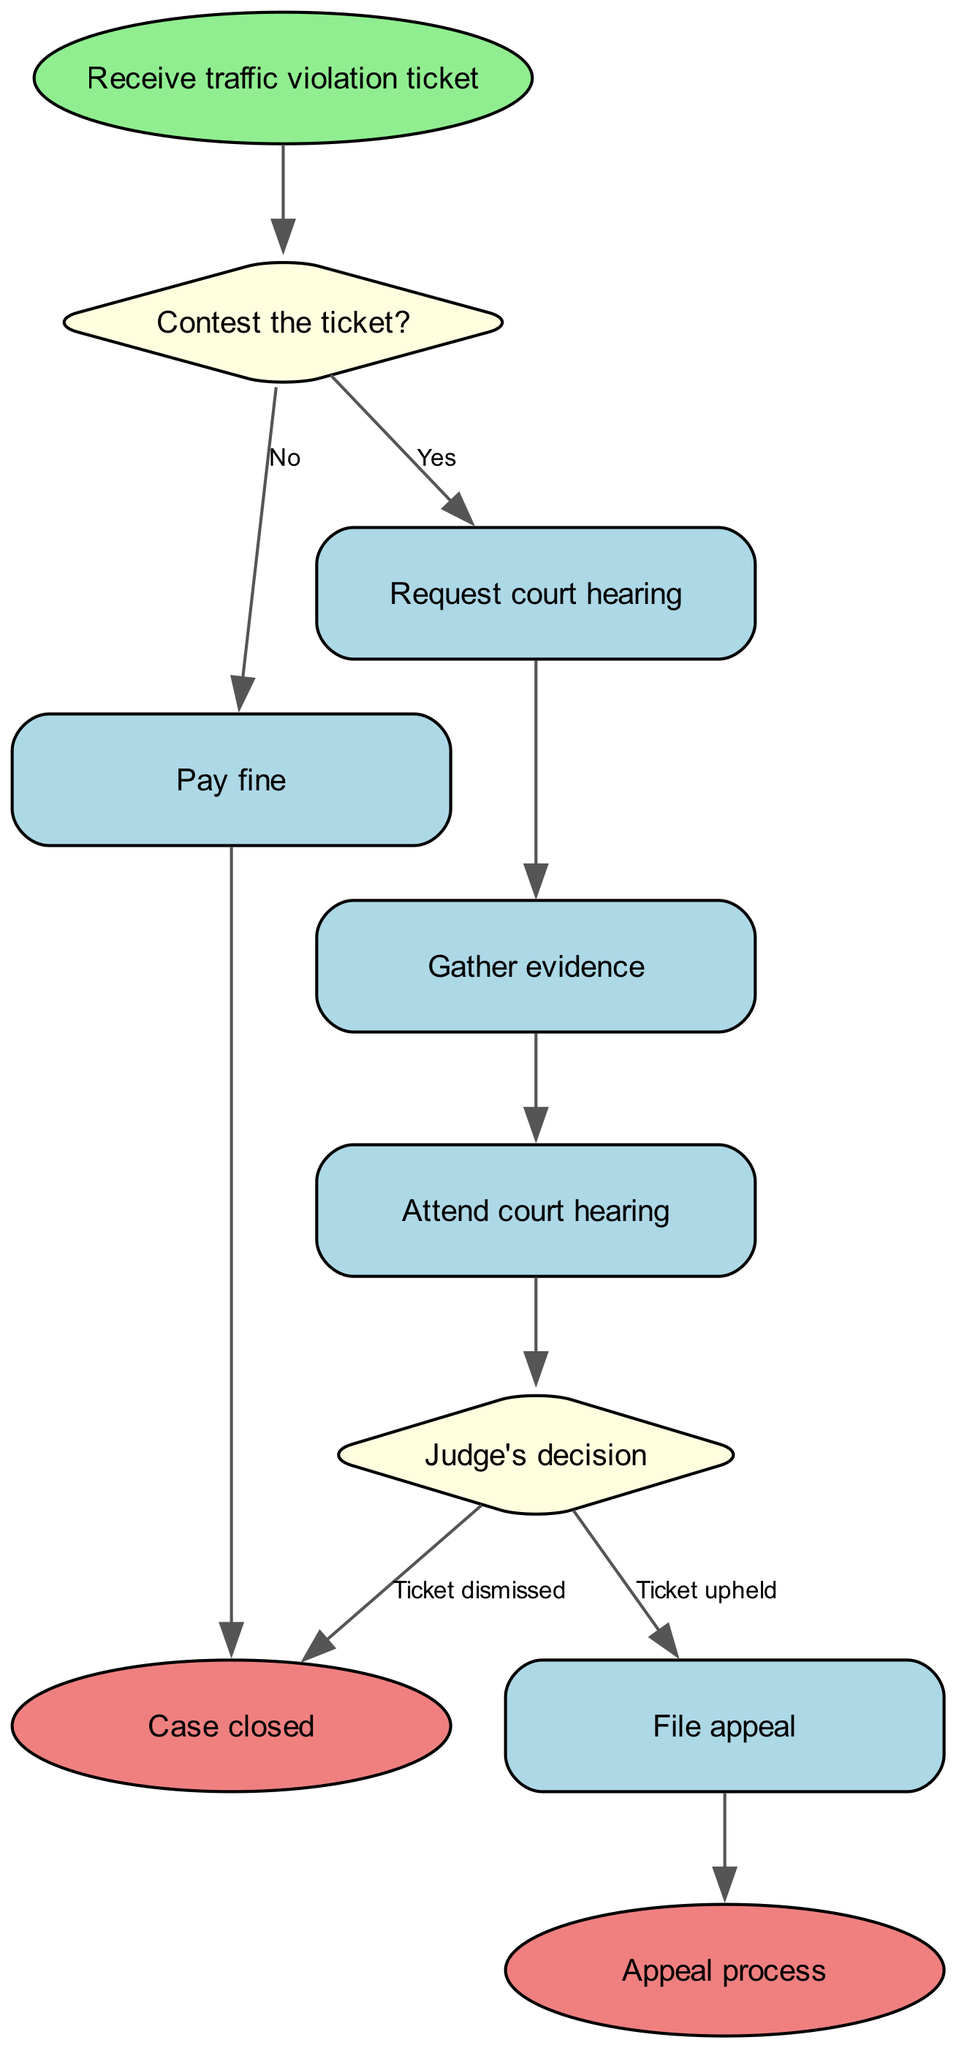What is the first step in the flowchart? The first step in the flowchart is represented by the "start" node, which states "Receive traffic violation ticket." This is clearly the initial action that triggers the entire process.
Answer: Receive traffic violation ticket How many decision nodes are present in the diagram? The diagram contains two decision nodes: "Contest the ticket?" and "Judge's decision." These nodes represent points where a choice is made in the flowchart.
Answer: 2 What happens if you decide to contest the traffic ticket? If you decide to contest the ticket, you move from the "Contest the ticket?" decision node to the "Request court hearing" process node. This indicates that contesting the ticket initiates further legal actions.
Answer: Request court hearing What step follows the court hearing? After attending the court hearing, the next step is the "Judge's decision" decision node. This shows that the outcome of the hearing leads to a judgment by the judge.
Answer: Judge's decision What is the outcome if the judge dismisses the ticket? If the judge dismisses the ticket, the process moves to the "Case closed" end node, indicating that no further action is required regarding the ticket.
Answer: Case closed What must be done if the ticket is upheld by the judge? If the ticket is upheld, you must proceed to "File appeal," which is a necessary action to contest the judge's decision further. This step indicates the continuation of the appeal process.
Answer: File appeal What is the final step in the appeal process? The last step in the appeal process is represented by the "Appeal process" end node, signifying that all actions regarding the appeal have been completed.
Answer: Appeal process What is indicated by the flow from "Process 1" (Pay fine) to "End 1"? The flow from "Process 1" to "End 1" indicates that if the individual chooses to pay the fine, the case is resolved, leading directly to the closure of the case without further action.
Answer: Case closed What happens after "Gather evidence"? After "Gather evidence," the next step is to "Attend court hearing," indicating that collecting evidence is a prerequisite for being present at the hearing.
Answer: Attend court hearing 